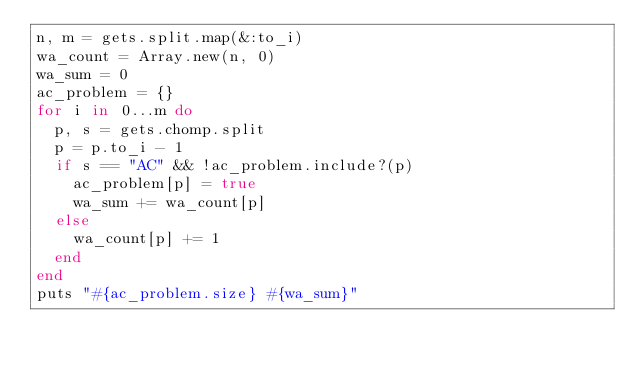Convert code to text. <code><loc_0><loc_0><loc_500><loc_500><_Ruby_>n, m = gets.split.map(&:to_i)
wa_count = Array.new(n, 0)
wa_sum = 0
ac_problem = {}
for i in 0...m do
  p, s = gets.chomp.split
  p = p.to_i - 1
  if s == "AC" && !ac_problem.include?(p)
    ac_problem[p] = true
    wa_sum += wa_count[p]
  else
    wa_count[p] += 1
  end
end
puts "#{ac_problem.size} #{wa_sum}"
</code> 